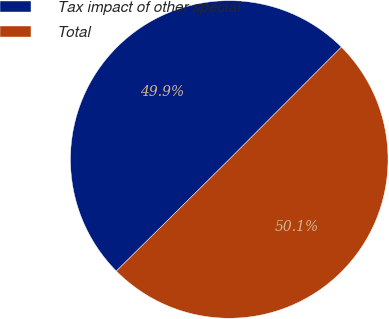Convert chart. <chart><loc_0><loc_0><loc_500><loc_500><pie_chart><fcel>Tax impact of other special<fcel>Total<nl><fcel>49.9%<fcel>50.1%<nl></chart> 